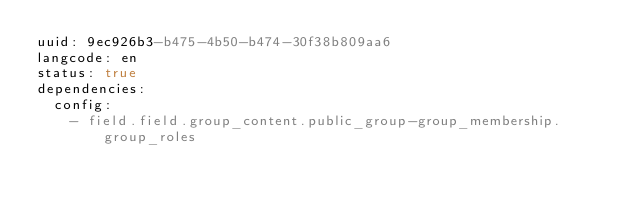Convert code to text. <code><loc_0><loc_0><loc_500><loc_500><_YAML_>uuid: 9ec926b3-b475-4b50-b474-30f38b809aa6
langcode: en
status: true
dependencies:
  config:
    - field.field.group_content.public_group-group_membership.group_roles</code> 